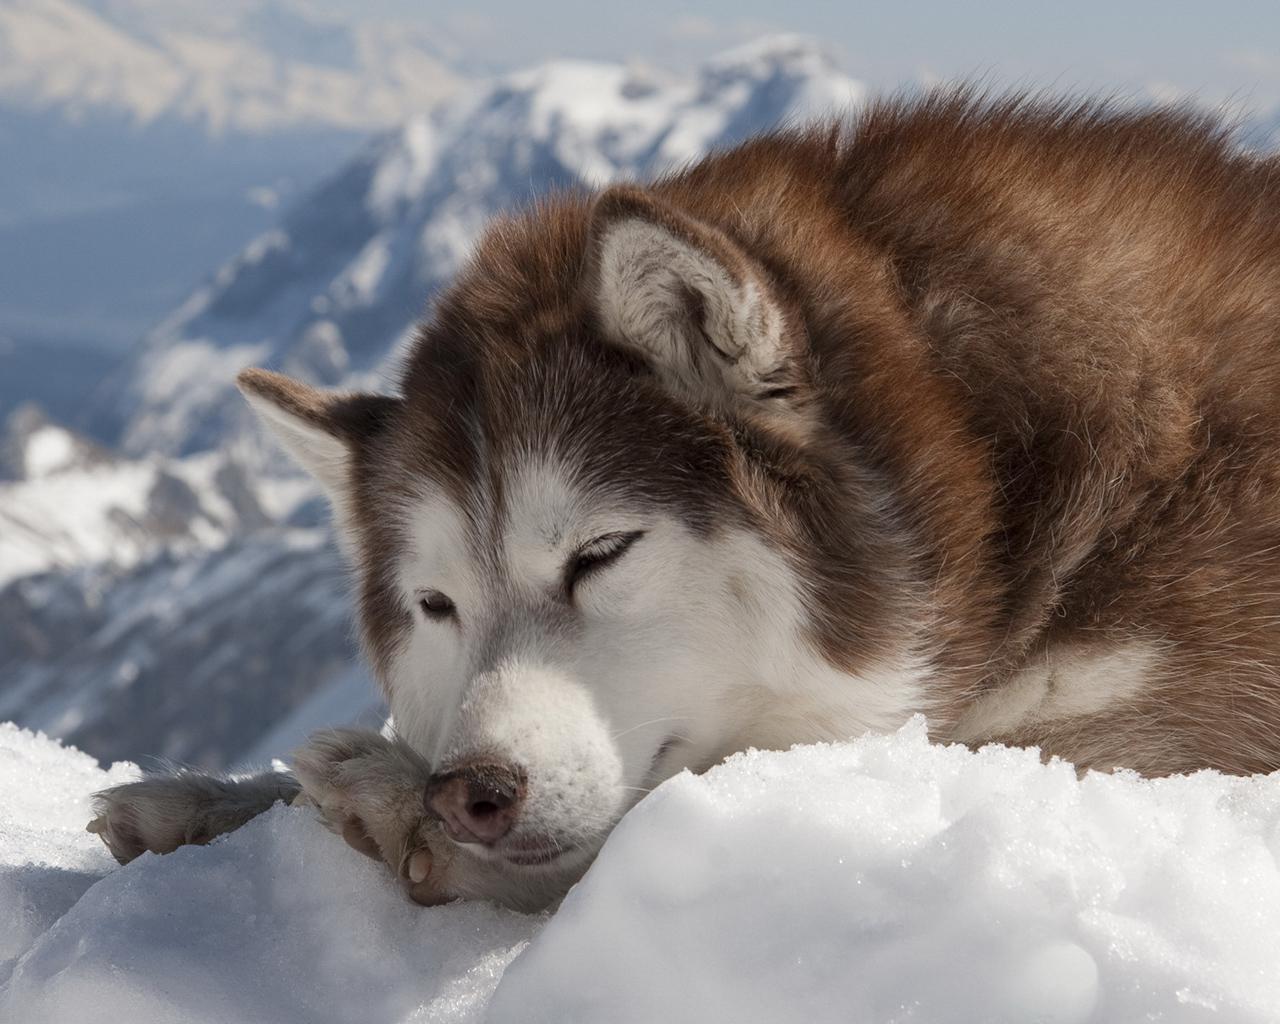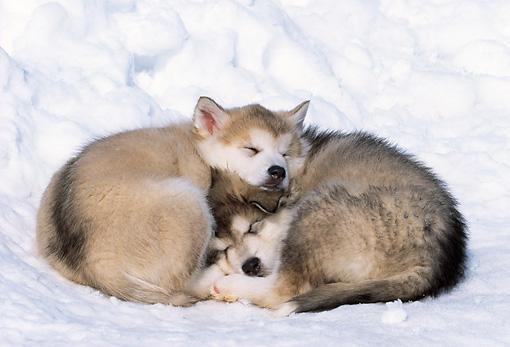The first image is the image on the left, the second image is the image on the right. For the images shown, is this caption "The left image shows one husky dog reclining with its nose pointed leftward, and the right image shows some type of animal with its head on top of a reclining husky." true? Answer yes or no. Yes. The first image is the image on the left, the second image is the image on the right. For the images shown, is this caption "There is exactly one dog that is sleeping in each image." true? Answer yes or no. No. 